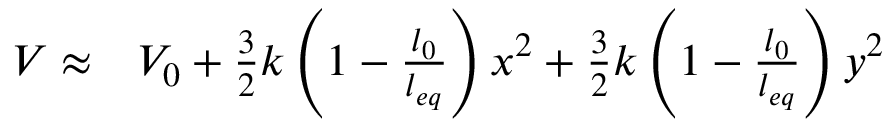<formula> <loc_0><loc_0><loc_500><loc_500>\begin{array} { r l } { V \approx } & V _ { 0 } + \frac { 3 } { 2 } k \left ( 1 - \frac { l _ { 0 } } { l _ { e q } } \right ) x ^ { 2 } + \frac { 3 } { 2 } k \left ( 1 - \frac { l _ { 0 } } { l _ { e q } } \right ) y ^ { 2 } } \end{array}</formula> 